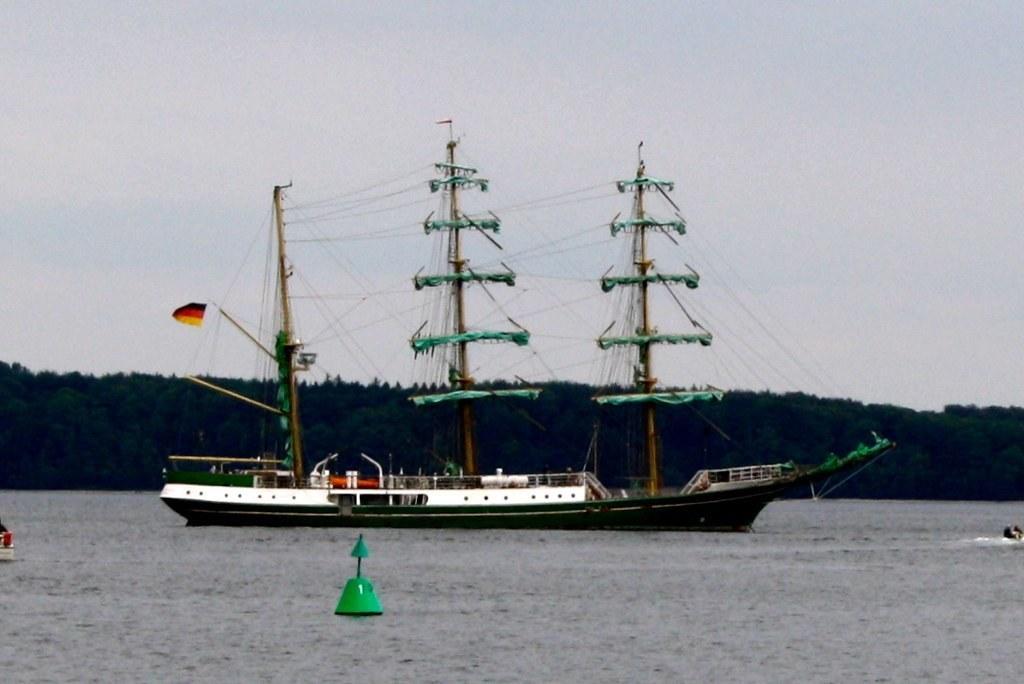Please provide a concise description of this image. In this picture we can see water at the bottom, there is a ship in the middle, on the right side and left side there are two boats, we can see trees in the background, there is the sky at the top of the picture. 